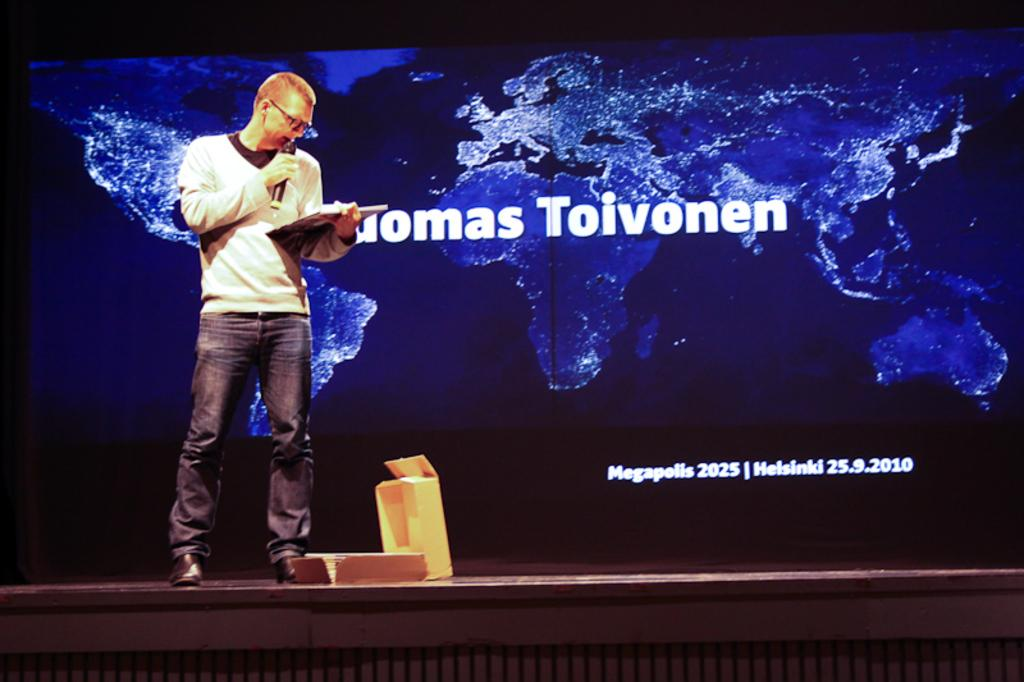<image>
Render a clear and concise summary of the photo. A man by the name of Thomas Toivonen is giving a speech on stage. 